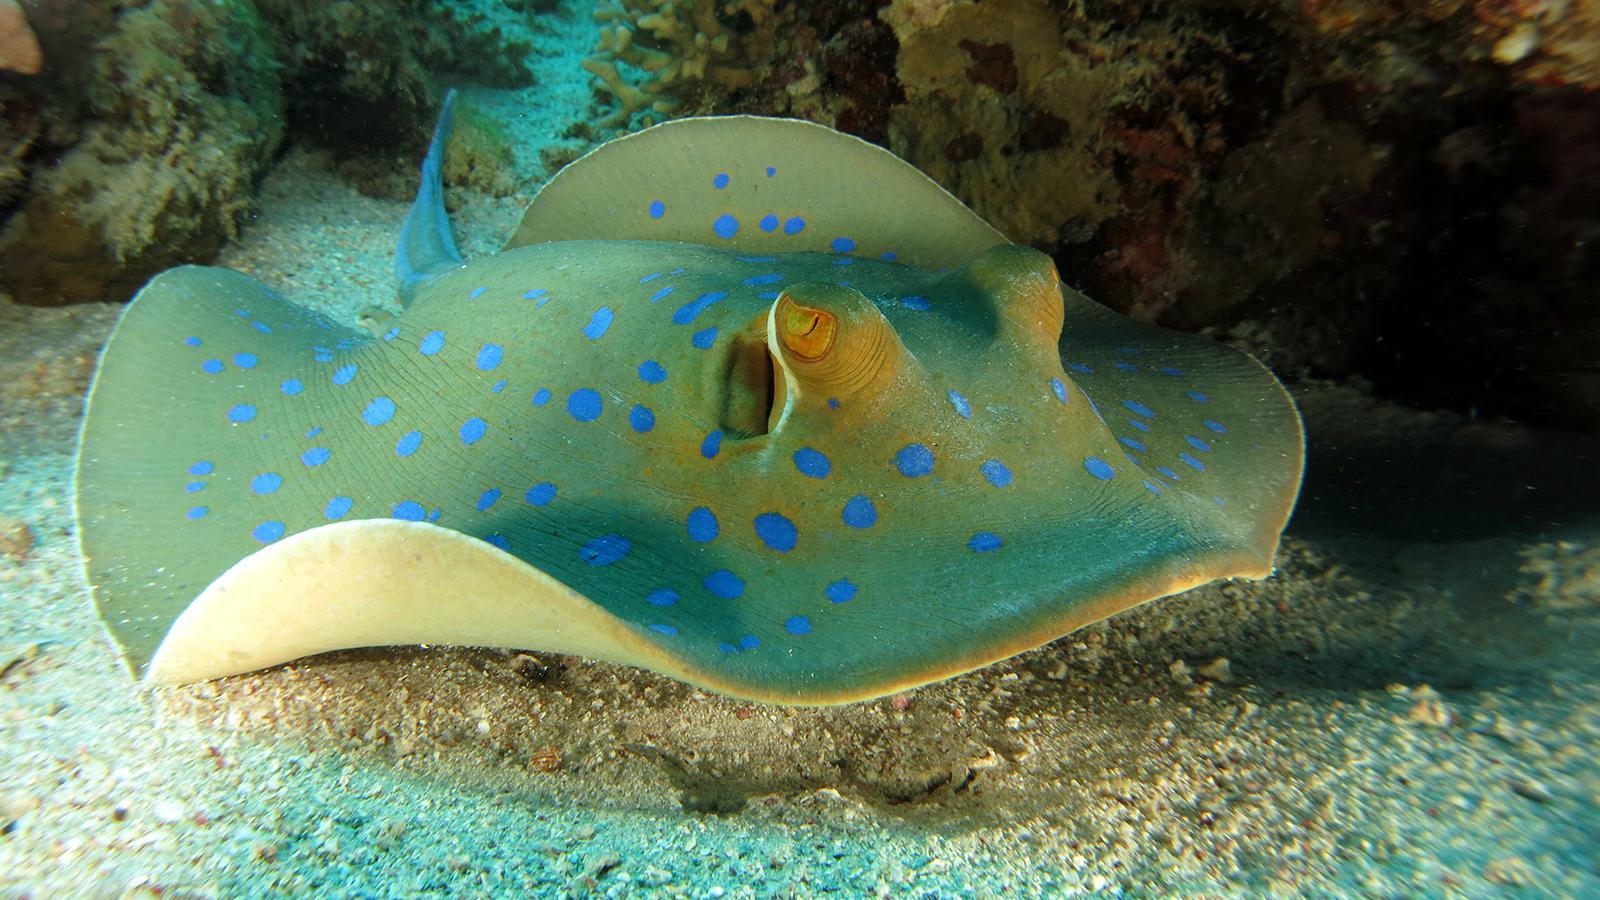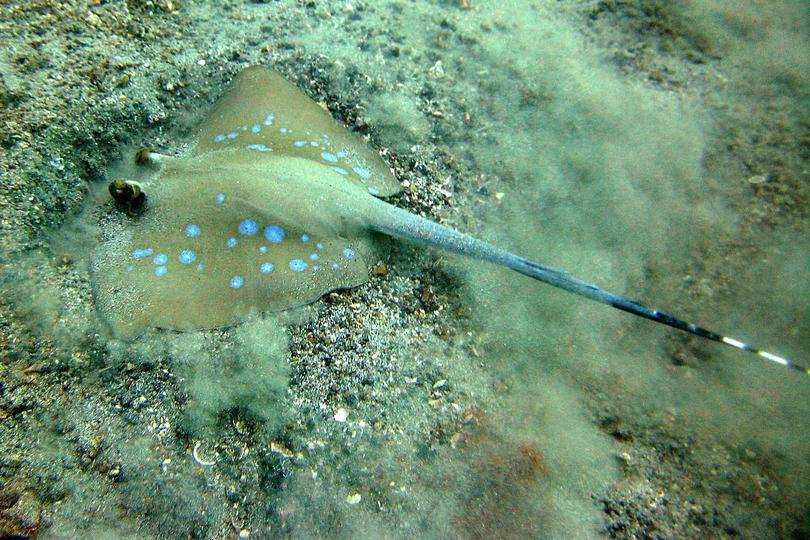The first image is the image on the left, the second image is the image on the right. Considering the images on both sides, is "The creature in the image on the right is pressed flat against the sea floor." valid? Answer yes or no. Yes. 